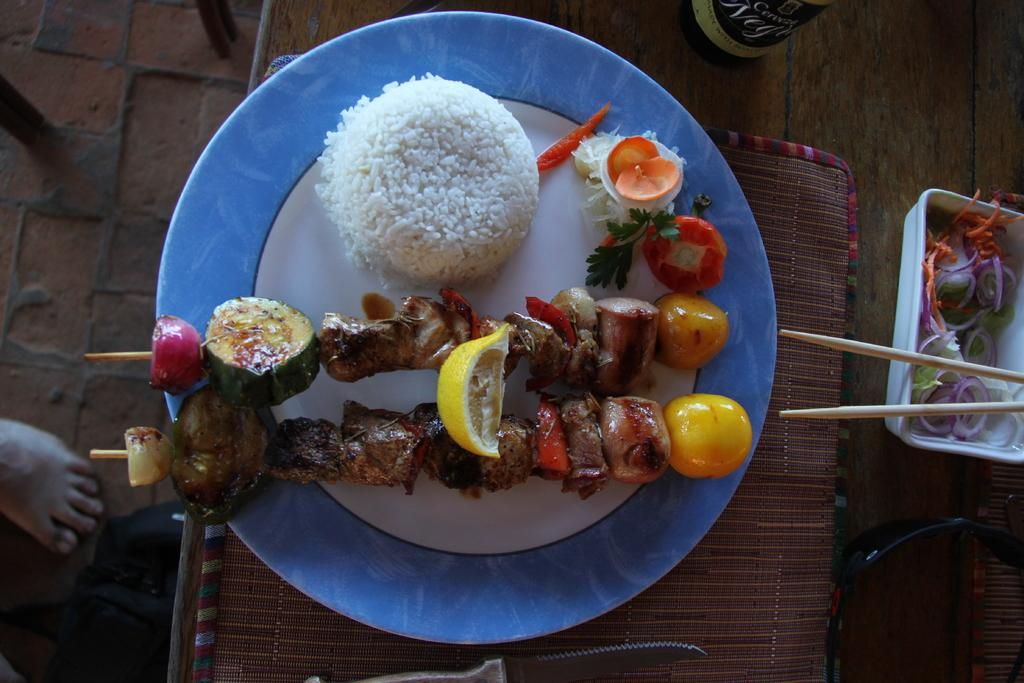What type of furniture is in the image? The image contains a table. What is placed on the table? There is a plate, a knife, chopsticks, a box, and food on the table. What utensils are visible on the table? A knife and chopsticks are visible on the table. What is inside the box on the table? The contents of the box are not visible in the image. Can you describe the person's foot visible on the floor? A person's foot is visible on the floor, but no other details about the foot or the person are provided. What type of locket is the person wearing in the image? There is no person wearing a locket in the image; only a foot is visible on the floor. Is the person wearing a hat in the image? There is no person wearing a hat in the image; only a foot is visible on the floor. 